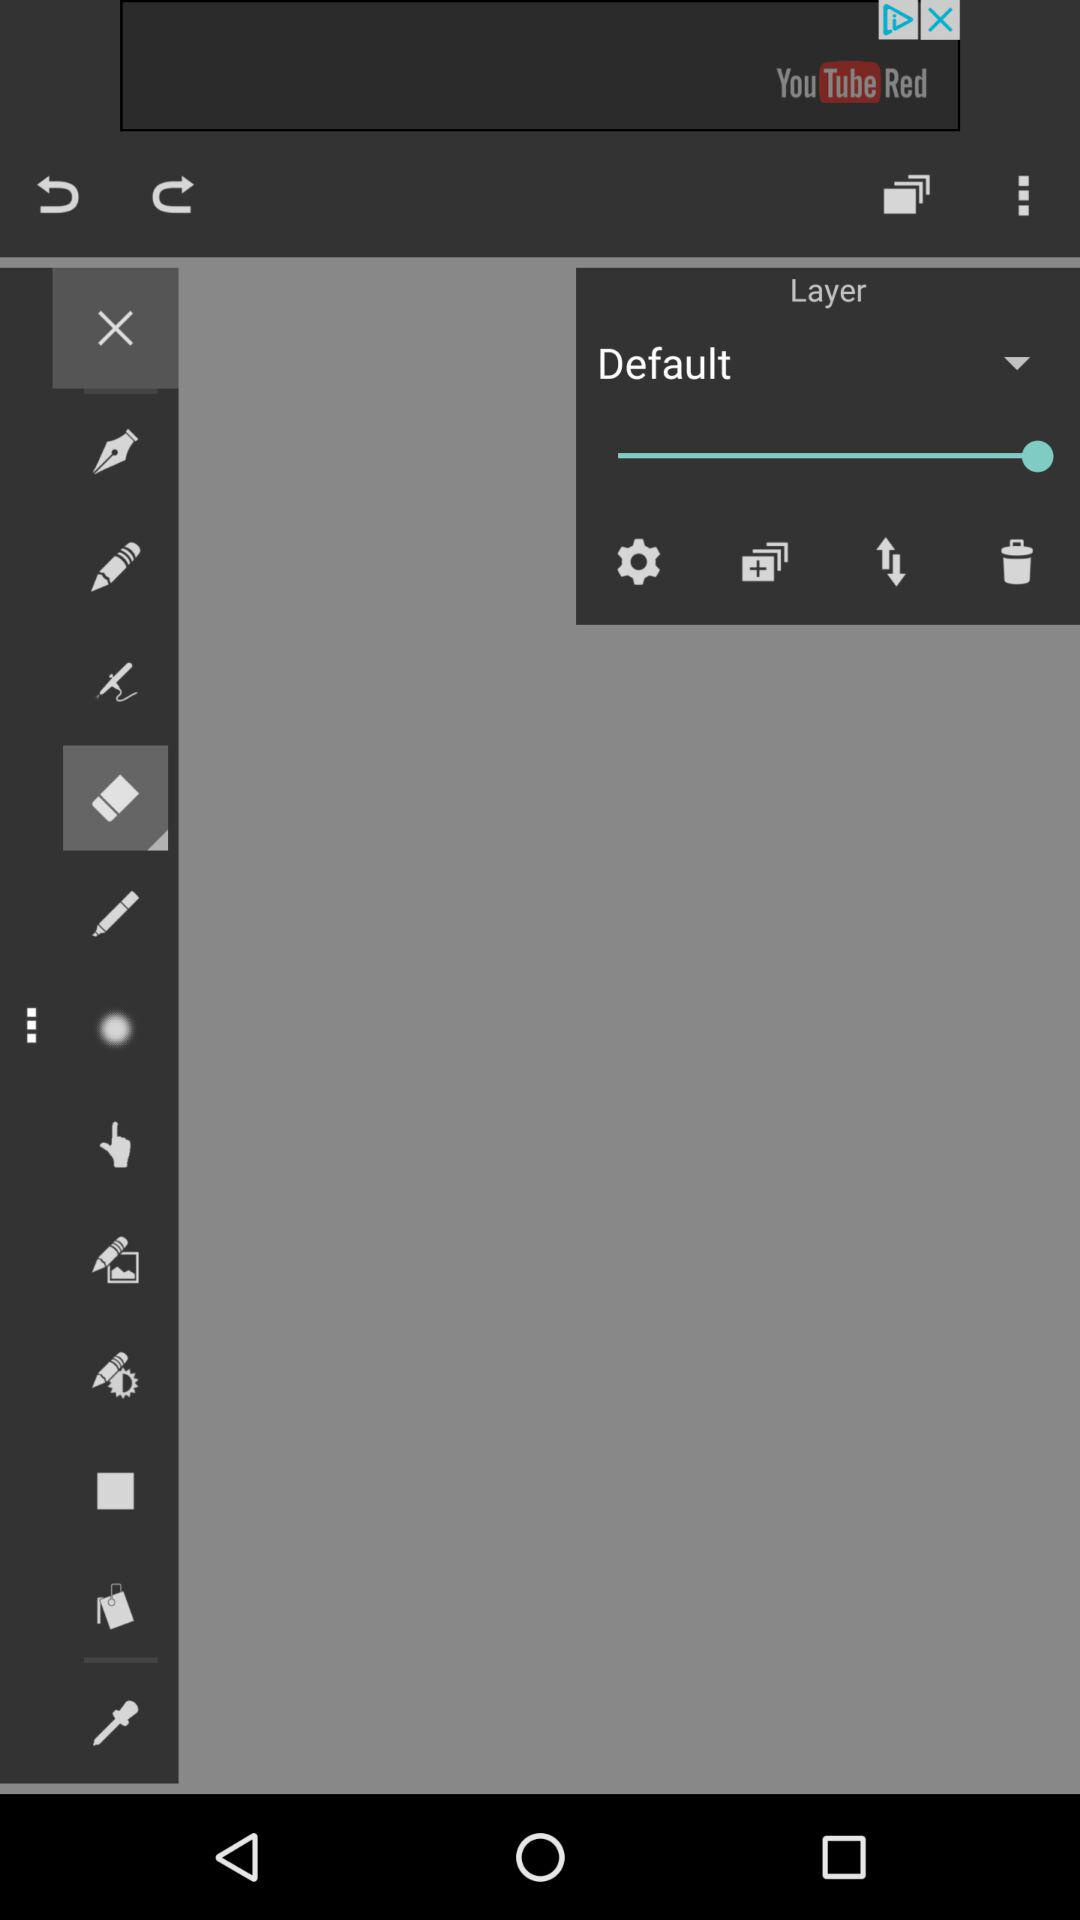Which tool is selected?
When the provided information is insufficient, respond with <no answer>. <no answer> 